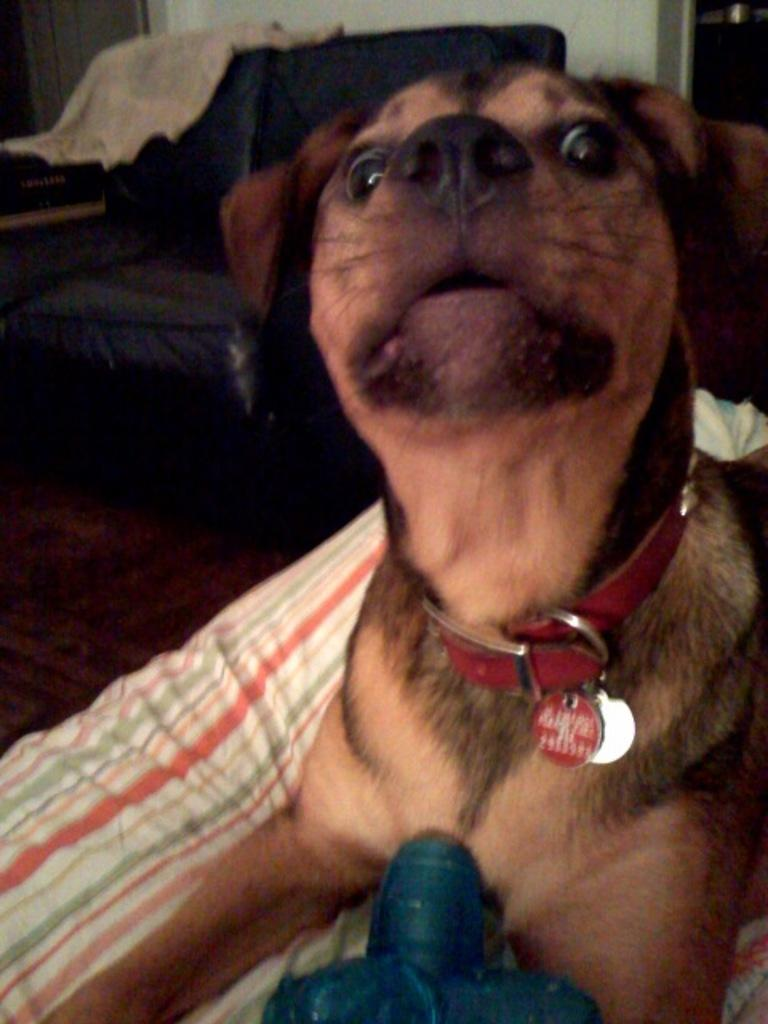What type of animal is present in the image? There is a brown dog in the image. What type of furniture is visible in the image? There is a couch in the image. What type of cloth is draped over the couch in the image? There is no cloth draped over the couch in the image. How many cats are visible in the image? There are no cats present in the image. Are there any bikes visible in the image? There are no bikes present in the image. 